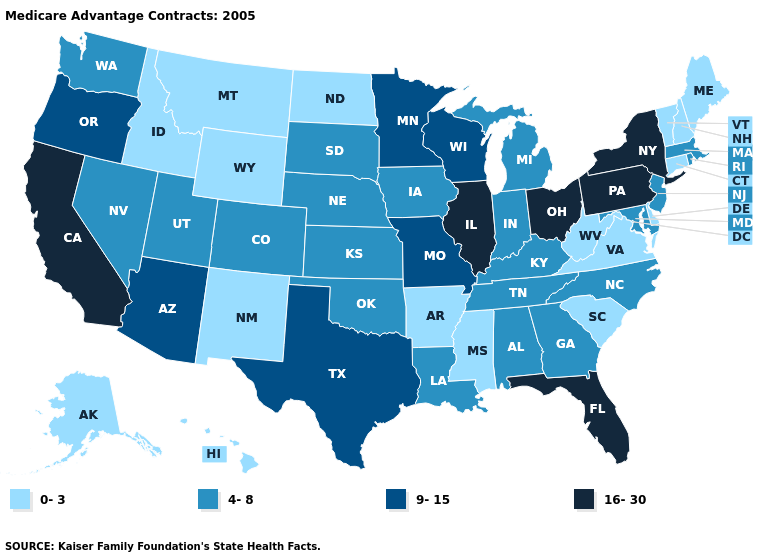Name the states that have a value in the range 0-3?
Write a very short answer. Alaska, Arkansas, Connecticut, Delaware, Hawaii, Idaho, Maine, Mississippi, Montana, North Dakota, New Hampshire, New Mexico, South Carolina, Virginia, Vermont, West Virginia, Wyoming. What is the highest value in the MidWest ?
Short answer required. 16-30. Name the states that have a value in the range 0-3?
Concise answer only. Alaska, Arkansas, Connecticut, Delaware, Hawaii, Idaho, Maine, Mississippi, Montana, North Dakota, New Hampshire, New Mexico, South Carolina, Virginia, Vermont, West Virginia, Wyoming. What is the highest value in the USA?
Answer briefly. 16-30. What is the highest value in the West ?
Keep it brief. 16-30. What is the highest value in the USA?
Keep it brief. 16-30. What is the value of New York?
Be succinct. 16-30. What is the value of Minnesota?
Quick response, please. 9-15. What is the lowest value in the USA?
Keep it brief. 0-3. What is the value of Texas?
Concise answer only. 9-15. What is the lowest value in states that border Tennessee?
Short answer required. 0-3. What is the value of Hawaii?
Short answer required. 0-3. Does Maine have the lowest value in the Northeast?
Short answer required. Yes. What is the lowest value in the USA?
Quick response, please. 0-3. What is the value of Maryland?
Be succinct. 4-8. 